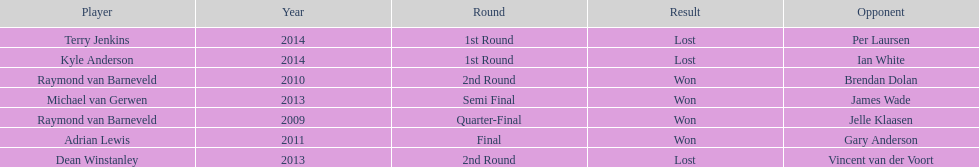Who was the last to win against his opponent? Michael van Gerwen. 